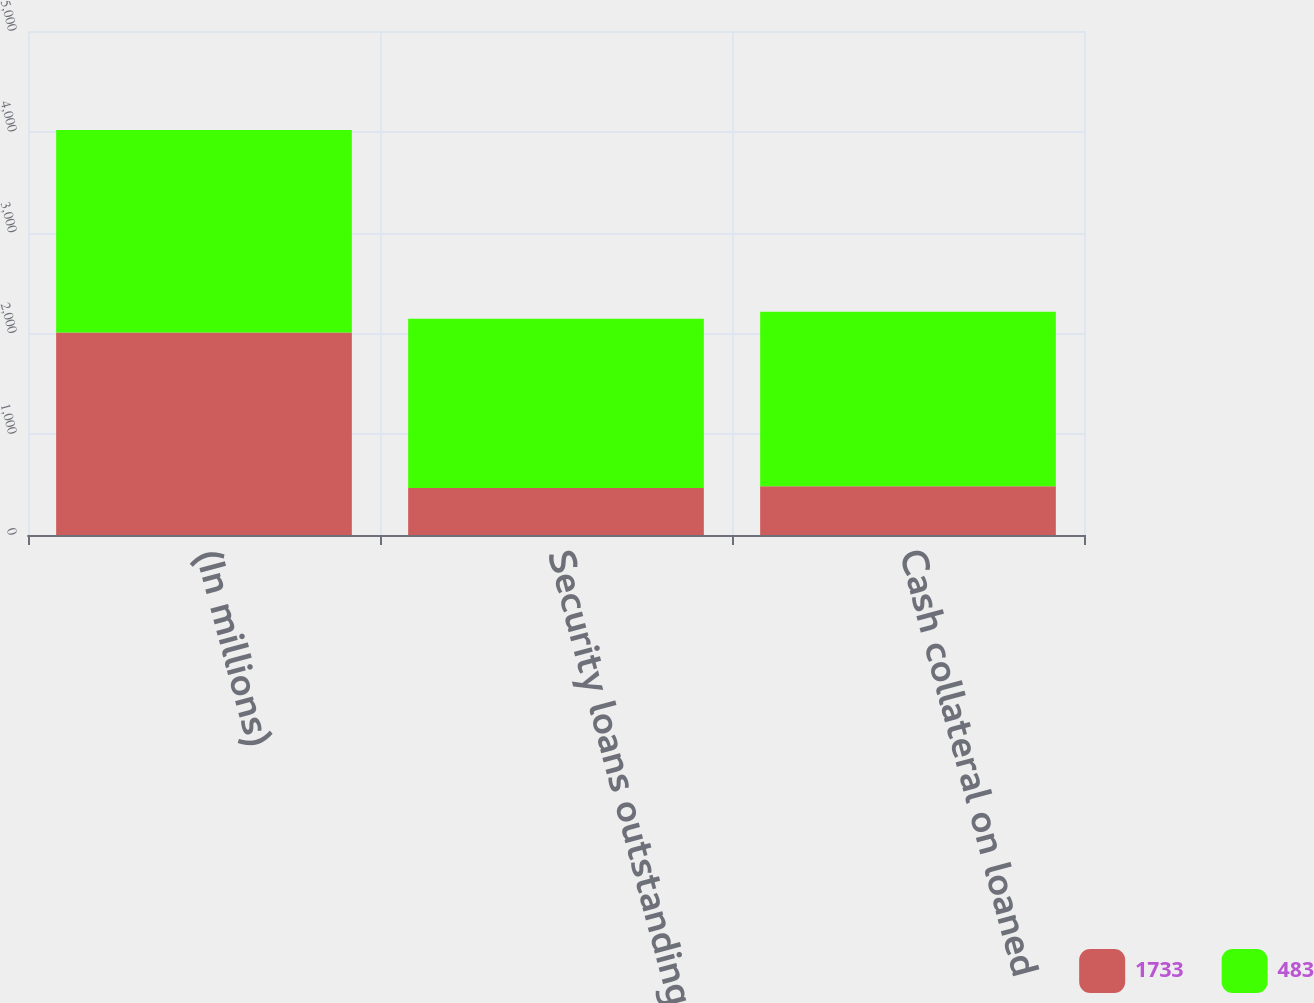Convert chart to OTSL. <chart><loc_0><loc_0><loc_500><loc_500><stacked_bar_chart><ecel><fcel>(In millions)<fcel>Security loans outstanding<fcel>Cash collateral on loaned<nl><fcel>1733<fcel>2009<fcel>467<fcel>483<nl><fcel>483<fcel>2008<fcel>1679<fcel>1733<nl></chart> 